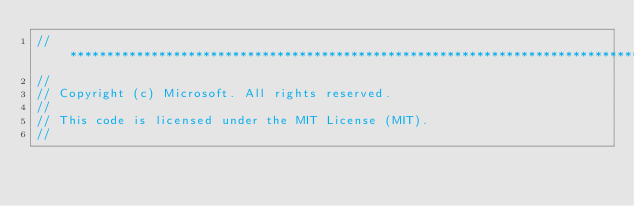<code> <loc_0><loc_0><loc_500><loc_500><_ObjectiveC_>//******************************************************************************
//
// Copyright (c) Microsoft. All rights reserved.
//
// This code is licensed under the MIT License (MIT).
//</code> 